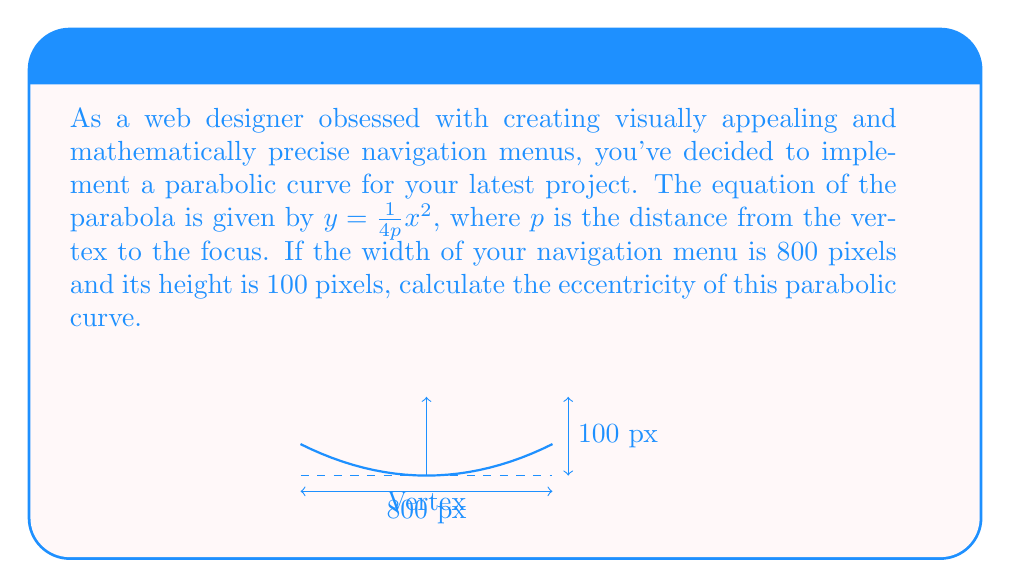What is the answer to this math problem? Let's approach this step-by-step:

1) The general equation of a parabola with vertex at the origin is $y = \frac{1}{4p}x^2$, where $p$ is the distance from the vertex to the focus.

2) We know the width is 800 pixels and the height is 100 pixels. Let's use these to find $p$:

   At $x = 400$ (half the width), $y = 100$

   $100 = \frac{1}{4p}(400)^2$

3) Solve for $p$:
   
   $100 = \frac{160000}{4p}$
   $400p = 160000$
   $p = 400$

4) The eccentricity of a parabola is always 1. This is a fundamental property of parabolas.

5) We can verify this using the formula for eccentricity of a conic section:

   $e = \sqrt{1 + \frac{b^2}{a^2}}$

   Where $a$ is the distance from the vertex to the focus (which is $p$ for a parabola), and $b$ is the length of the semi-minor axis (which doesn't exist for a parabola, so it's 0).

   $e = \sqrt{1 + \frac{0^2}{400^2}} = \sqrt{1 + 0} = 1$

Therefore, the eccentricity of the parabolic navigation menu curve is 1.
Answer: $1$ 